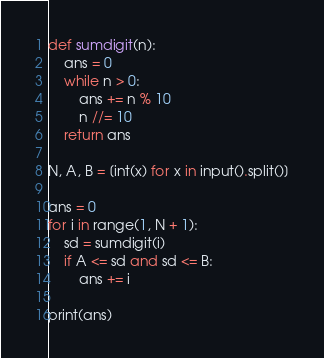<code> <loc_0><loc_0><loc_500><loc_500><_Python_>def sumdigit(n):
    ans = 0
    while n > 0:
        ans += n % 10
        n //= 10
    return ans

N, A, B = [int(x) for x in input().split()]

ans = 0
for i in range(1, N + 1):
    sd = sumdigit(i)
    if A <= sd and sd <= B:
        ans += i

print(ans)
</code> 